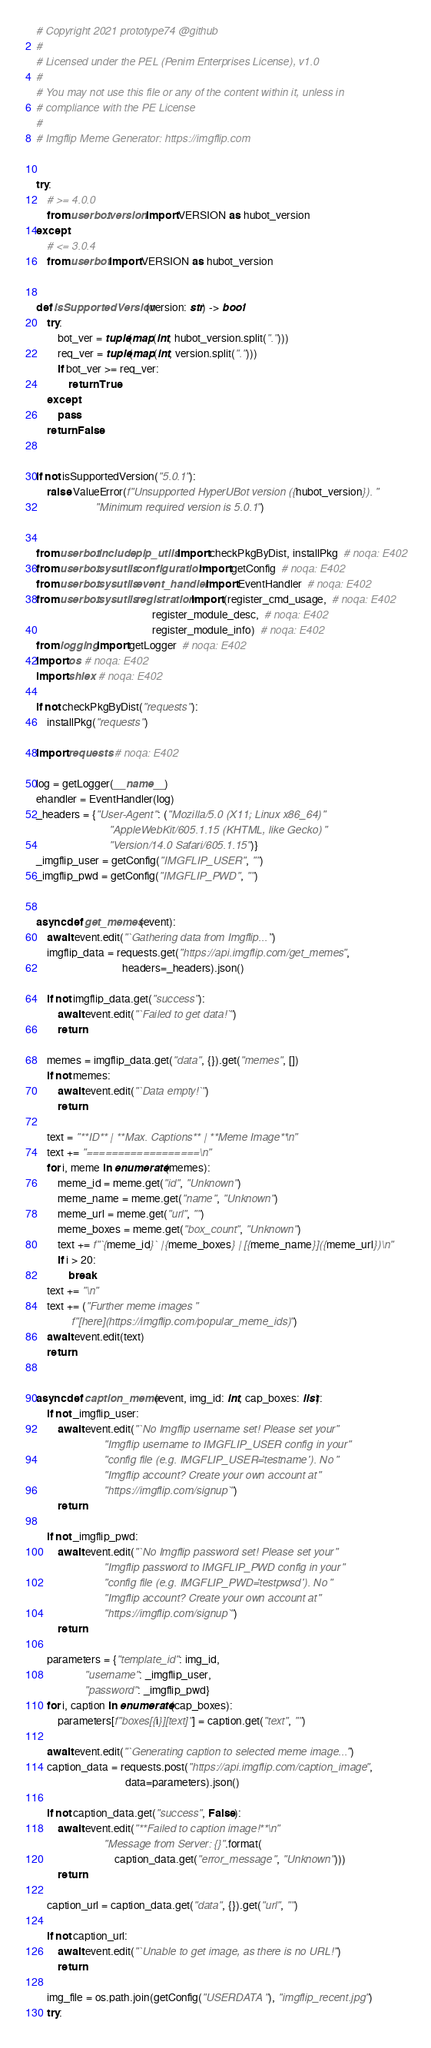Convert code to text. <code><loc_0><loc_0><loc_500><loc_500><_Python_># Copyright 2021 prototype74 @github
#
# Licensed under the PEL (Penim Enterprises License), v1.0
#
# You may not use this file or any of the content within it, unless in
# compliance with the PE License
#
# Imgflip Meme Generator: https://imgflip.com


try:
    # >= 4.0.0
    from userbot.version import VERSION as hubot_version
except:
    # <= 3.0.4
    from userbot import VERSION as hubot_version


def isSupportedVersion(version: str) -> bool:
    try:
        bot_ver = tuple(map(int, hubot_version.split(".")))
        req_ver = tuple(map(int, version.split(".")))
        if bot_ver >= req_ver:
            return True
    except:
        pass
    return False


if not isSupportedVersion("5.0.1"):
    raise ValueError(f"Unsupported HyperUBot version ({hubot_version}). "
                      "Minimum required version is 5.0.1")


from userbot.include.pip_utils import checkPkgByDist, installPkg  # noqa: E402
from userbot.sysutils.configuration import getConfig  # noqa: E402
from userbot.sysutils.event_handler import EventHandler  # noqa: E402
from userbot.sysutils.registration import (register_cmd_usage,  # noqa: E402
                                           register_module_desc,  # noqa: E402
                                           register_module_info)  # noqa: E402
from logging import getLogger  # noqa: E402
import os  # noqa: E402
import shlex  # noqa: E402

if not checkPkgByDist("requests"):
    installPkg("requests")

import requests  # noqa: E402

log = getLogger(__name__)
ehandler = EventHandler(log)
_headers = {"User-Agent": ("Mozilla/5.0 (X11; Linux x86_64) "
                           "AppleWebKit/605.1.15 (KHTML, like Gecko) "
                           "Version/14.0 Safari/605.1.15")}
_imgflip_user = getConfig("IMGFLIP_USER", "")
_imgflip_pwd = getConfig("IMGFLIP_PWD", "")


async def get_memes(event):
    await event.edit("`Gathering data from Imgflip...`")
    imgflip_data = requests.get("https://api.imgflip.com/get_memes",
                                headers=_headers).json()

    if not imgflip_data.get("success"):
        await event.edit("`Failed to get data!`")
        return

    memes = imgflip_data.get("data", {}).get("memes", [])
    if not memes:
        await event.edit("`Data empty!`")
        return

    text = "**ID** | **Max. Captions** | **Meme Image**\n"
    text += "==================\n"
    for i, meme in enumerate(memes):
        meme_id = meme.get("id", "Unknown")
        meme_name = meme.get("name", "Unknown")
        meme_url = meme.get("url", "")
        meme_boxes = meme.get("box_count", "Unknown")
        text += f"`{meme_id}` | {meme_boxes} | [{meme_name}]({meme_url})\n"
        if i > 20:
            break
    text += "\n"
    text += ("Further meme images "
             f"[here](https://imgflip.com/popular_meme_ids)")
    await event.edit(text)
    return


async def caption_meme(event, img_id: int, cap_boxes: list):
    if not _imgflip_user:
        await event.edit("`No Imgflip username set! Please set your "
                         "Imgflip username to IMGFLIP_USER config in your "
                         "config file (e.g. IMGFLIP_USER='testname'). No "
                         "Imgflip account? Create your own account at "
                         "https://imgflip.com/signup`")
        return

    if not _imgflip_pwd:
        await event.edit("`No Imgflip password set! Please set your "
                         "Imgflip password to IMGFLIP_PWD config in your "
                         "config file (e.g. IMGFLIP_PWD='testpwsd'). No "
                         "Imgflip account? Create your own account at "
                         "https://imgflip.com/signup`")
        return

    parameters = {"template_id": img_id,
                  "username": _imgflip_user,
                  "password": _imgflip_pwd}
    for i, caption in enumerate(cap_boxes):
        parameters[f"boxes[{i}][text]"] = caption.get("text", "")

    await event.edit("`Generating caption to selected meme image...`")
    caption_data = requests.post("https://api.imgflip.com/caption_image",
                                 data=parameters).json()

    if not caption_data.get("success", False):
        await event.edit("**Failed to caption image!**\n"
                         "Message from Server: {}".format(
                             caption_data.get("error_message", "Unknown")))
        return

    caption_url = caption_data.get("data", {}).get("url", "")

    if not caption_url:
        await event.edit("`Unable to get image, as there is no URL!`")
        return

    img_file = os.path.join(getConfig("USERDATA"), "imgflip_recent.jpg")
    try:</code> 